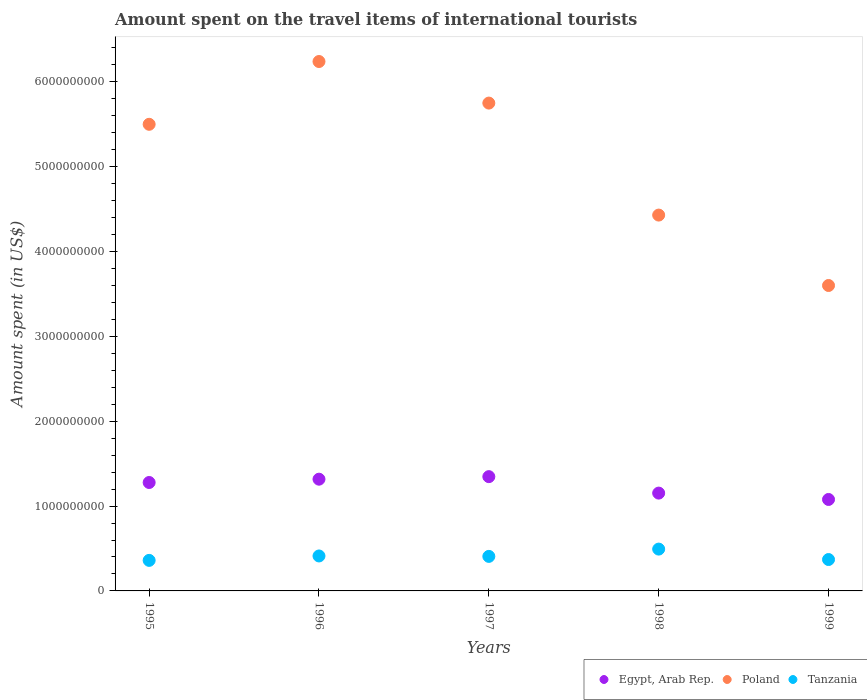How many different coloured dotlines are there?
Your response must be concise. 3. What is the amount spent on the travel items of international tourists in Poland in 1997?
Your response must be concise. 5.75e+09. Across all years, what is the maximum amount spent on the travel items of international tourists in Poland?
Offer a very short reply. 6.24e+09. Across all years, what is the minimum amount spent on the travel items of international tourists in Tanzania?
Your answer should be compact. 3.60e+08. In which year was the amount spent on the travel items of international tourists in Poland minimum?
Make the answer very short. 1999. What is the total amount spent on the travel items of international tourists in Tanzania in the graph?
Your answer should be compact. 2.04e+09. What is the difference between the amount spent on the travel items of international tourists in Egypt, Arab Rep. in 1998 and that in 1999?
Your answer should be very brief. 7.50e+07. What is the difference between the amount spent on the travel items of international tourists in Egypt, Arab Rep. in 1999 and the amount spent on the travel items of international tourists in Tanzania in 1996?
Your response must be concise. 6.66e+08. What is the average amount spent on the travel items of international tourists in Poland per year?
Provide a short and direct response. 5.10e+09. In the year 1996, what is the difference between the amount spent on the travel items of international tourists in Tanzania and amount spent on the travel items of international tourists in Egypt, Arab Rep.?
Make the answer very short. -9.05e+08. What is the ratio of the amount spent on the travel items of international tourists in Tanzania in 1997 to that in 1998?
Your answer should be compact. 0.83. What is the difference between the highest and the second highest amount spent on the travel items of international tourists in Poland?
Ensure brevity in your answer.  4.90e+08. What is the difference between the highest and the lowest amount spent on the travel items of international tourists in Poland?
Provide a succinct answer. 2.64e+09. Is it the case that in every year, the sum of the amount spent on the travel items of international tourists in Poland and amount spent on the travel items of international tourists in Tanzania  is greater than the amount spent on the travel items of international tourists in Egypt, Arab Rep.?
Ensure brevity in your answer.  Yes. Does the amount spent on the travel items of international tourists in Tanzania monotonically increase over the years?
Your answer should be very brief. No. How many dotlines are there?
Provide a succinct answer. 3. How many years are there in the graph?
Make the answer very short. 5. Where does the legend appear in the graph?
Provide a succinct answer. Bottom right. How many legend labels are there?
Provide a short and direct response. 3. What is the title of the graph?
Your response must be concise. Amount spent on the travel items of international tourists. What is the label or title of the Y-axis?
Give a very brief answer. Amount spent (in US$). What is the Amount spent (in US$) in Egypt, Arab Rep. in 1995?
Offer a very short reply. 1.28e+09. What is the Amount spent (in US$) of Poland in 1995?
Your response must be concise. 5.50e+09. What is the Amount spent (in US$) in Tanzania in 1995?
Make the answer very short. 3.60e+08. What is the Amount spent (in US$) in Egypt, Arab Rep. in 1996?
Give a very brief answer. 1.32e+09. What is the Amount spent (in US$) in Poland in 1996?
Ensure brevity in your answer.  6.24e+09. What is the Amount spent (in US$) in Tanzania in 1996?
Give a very brief answer. 4.12e+08. What is the Amount spent (in US$) in Egypt, Arab Rep. in 1997?
Offer a terse response. 1.35e+09. What is the Amount spent (in US$) in Poland in 1997?
Give a very brief answer. 5.75e+09. What is the Amount spent (in US$) in Tanzania in 1997?
Your answer should be compact. 4.07e+08. What is the Amount spent (in US$) of Egypt, Arab Rep. in 1998?
Provide a short and direct response. 1.15e+09. What is the Amount spent (in US$) of Poland in 1998?
Offer a terse response. 4.43e+09. What is the Amount spent (in US$) of Tanzania in 1998?
Your response must be concise. 4.93e+08. What is the Amount spent (in US$) of Egypt, Arab Rep. in 1999?
Your answer should be compact. 1.08e+09. What is the Amount spent (in US$) of Poland in 1999?
Keep it short and to the point. 3.60e+09. What is the Amount spent (in US$) in Tanzania in 1999?
Your response must be concise. 3.70e+08. Across all years, what is the maximum Amount spent (in US$) of Egypt, Arab Rep.?
Make the answer very short. 1.35e+09. Across all years, what is the maximum Amount spent (in US$) of Poland?
Provide a short and direct response. 6.24e+09. Across all years, what is the maximum Amount spent (in US$) of Tanzania?
Offer a terse response. 4.93e+08. Across all years, what is the minimum Amount spent (in US$) of Egypt, Arab Rep.?
Keep it short and to the point. 1.08e+09. Across all years, what is the minimum Amount spent (in US$) of Poland?
Offer a very short reply. 3.60e+09. Across all years, what is the minimum Amount spent (in US$) of Tanzania?
Make the answer very short. 3.60e+08. What is the total Amount spent (in US$) in Egypt, Arab Rep. in the graph?
Your answer should be compact. 6.17e+09. What is the total Amount spent (in US$) of Poland in the graph?
Offer a very short reply. 2.55e+1. What is the total Amount spent (in US$) in Tanzania in the graph?
Make the answer very short. 2.04e+09. What is the difference between the Amount spent (in US$) in Egypt, Arab Rep. in 1995 and that in 1996?
Your answer should be very brief. -3.90e+07. What is the difference between the Amount spent (in US$) in Poland in 1995 and that in 1996?
Your answer should be compact. -7.40e+08. What is the difference between the Amount spent (in US$) in Tanzania in 1995 and that in 1996?
Offer a terse response. -5.20e+07. What is the difference between the Amount spent (in US$) of Egypt, Arab Rep. in 1995 and that in 1997?
Your answer should be compact. -6.90e+07. What is the difference between the Amount spent (in US$) in Poland in 1995 and that in 1997?
Provide a short and direct response. -2.50e+08. What is the difference between the Amount spent (in US$) of Tanzania in 1995 and that in 1997?
Your answer should be very brief. -4.70e+07. What is the difference between the Amount spent (in US$) of Egypt, Arab Rep. in 1995 and that in 1998?
Your answer should be compact. 1.25e+08. What is the difference between the Amount spent (in US$) of Poland in 1995 and that in 1998?
Keep it short and to the point. 1.07e+09. What is the difference between the Amount spent (in US$) in Tanzania in 1995 and that in 1998?
Keep it short and to the point. -1.33e+08. What is the difference between the Amount spent (in US$) of Poland in 1995 and that in 1999?
Your response must be concise. 1.90e+09. What is the difference between the Amount spent (in US$) in Tanzania in 1995 and that in 1999?
Make the answer very short. -1.00e+07. What is the difference between the Amount spent (in US$) in Egypt, Arab Rep. in 1996 and that in 1997?
Offer a very short reply. -3.00e+07. What is the difference between the Amount spent (in US$) in Poland in 1996 and that in 1997?
Make the answer very short. 4.90e+08. What is the difference between the Amount spent (in US$) of Egypt, Arab Rep. in 1996 and that in 1998?
Give a very brief answer. 1.64e+08. What is the difference between the Amount spent (in US$) in Poland in 1996 and that in 1998?
Your answer should be compact. 1.81e+09. What is the difference between the Amount spent (in US$) in Tanzania in 1996 and that in 1998?
Keep it short and to the point. -8.10e+07. What is the difference between the Amount spent (in US$) in Egypt, Arab Rep. in 1996 and that in 1999?
Offer a terse response. 2.39e+08. What is the difference between the Amount spent (in US$) of Poland in 1996 and that in 1999?
Offer a terse response. 2.64e+09. What is the difference between the Amount spent (in US$) in Tanzania in 1996 and that in 1999?
Make the answer very short. 4.20e+07. What is the difference between the Amount spent (in US$) of Egypt, Arab Rep. in 1997 and that in 1998?
Your answer should be compact. 1.94e+08. What is the difference between the Amount spent (in US$) in Poland in 1997 and that in 1998?
Keep it short and to the point. 1.32e+09. What is the difference between the Amount spent (in US$) in Tanzania in 1997 and that in 1998?
Your answer should be compact. -8.60e+07. What is the difference between the Amount spent (in US$) in Egypt, Arab Rep. in 1997 and that in 1999?
Provide a short and direct response. 2.69e+08. What is the difference between the Amount spent (in US$) in Poland in 1997 and that in 1999?
Offer a terse response. 2.15e+09. What is the difference between the Amount spent (in US$) in Tanzania in 1997 and that in 1999?
Provide a succinct answer. 3.70e+07. What is the difference between the Amount spent (in US$) of Egypt, Arab Rep. in 1998 and that in 1999?
Give a very brief answer. 7.50e+07. What is the difference between the Amount spent (in US$) in Poland in 1998 and that in 1999?
Make the answer very short. 8.30e+08. What is the difference between the Amount spent (in US$) of Tanzania in 1998 and that in 1999?
Your response must be concise. 1.23e+08. What is the difference between the Amount spent (in US$) in Egypt, Arab Rep. in 1995 and the Amount spent (in US$) in Poland in 1996?
Provide a succinct answer. -4.96e+09. What is the difference between the Amount spent (in US$) in Egypt, Arab Rep. in 1995 and the Amount spent (in US$) in Tanzania in 1996?
Your answer should be compact. 8.66e+08. What is the difference between the Amount spent (in US$) of Poland in 1995 and the Amount spent (in US$) of Tanzania in 1996?
Offer a very short reply. 5.09e+09. What is the difference between the Amount spent (in US$) in Egypt, Arab Rep. in 1995 and the Amount spent (in US$) in Poland in 1997?
Keep it short and to the point. -4.47e+09. What is the difference between the Amount spent (in US$) of Egypt, Arab Rep. in 1995 and the Amount spent (in US$) of Tanzania in 1997?
Offer a very short reply. 8.71e+08. What is the difference between the Amount spent (in US$) of Poland in 1995 and the Amount spent (in US$) of Tanzania in 1997?
Make the answer very short. 5.09e+09. What is the difference between the Amount spent (in US$) of Egypt, Arab Rep. in 1995 and the Amount spent (in US$) of Poland in 1998?
Provide a succinct answer. -3.15e+09. What is the difference between the Amount spent (in US$) of Egypt, Arab Rep. in 1995 and the Amount spent (in US$) of Tanzania in 1998?
Offer a terse response. 7.85e+08. What is the difference between the Amount spent (in US$) of Poland in 1995 and the Amount spent (in US$) of Tanzania in 1998?
Offer a terse response. 5.01e+09. What is the difference between the Amount spent (in US$) in Egypt, Arab Rep. in 1995 and the Amount spent (in US$) in Poland in 1999?
Your answer should be compact. -2.32e+09. What is the difference between the Amount spent (in US$) of Egypt, Arab Rep. in 1995 and the Amount spent (in US$) of Tanzania in 1999?
Your answer should be compact. 9.08e+08. What is the difference between the Amount spent (in US$) of Poland in 1995 and the Amount spent (in US$) of Tanzania in 1999?
Your response must be concise. 5.13e+09. What is the difference between the Amount spent (in US$) of Egypt, Arab Rep. in 1996 and the Amount spent (in US$) of Poland in 1997?
Offer a very short reply. -4.43e+09. What is the difference between the Amount spent (in US$) in Egypt, Arab Rep. in 1996 and the Amount spent (in US$) in Tanzania in 1997?
Ensure brevity in your answer.  9.10e+08. What is the difference between the Amount spent (in US$) of Poland in 1996 and the Amount spent (in US$) of Tanzania in 1997?
Give a very brief answer. 5.83e+09. What is the difference between the Amount spent (in US$) in Egypt, Arab Rep. in 1996 and the Amount spent (in US$) in Poland in 1998?
Your answer should be very brief. -3.11e+09. What is the difference between the Amount spent (in US$) in Egypt, Arab Rep. in 1996 and the Amount spent (in US$) in Tanzania in 1998?
Your answer should be very brief. 8.24e+08. What is the difference between the Amount spent (in US$) in Poland in 1996 and the Amount spent (in US$) in Tanzania in 1998?
Keep it short and to the point. 5.75e+09. What is the difference between the Amount spent (in US$) in Egypt, Arab Rep. in 1996 and the Amount spent (in US$) in Poland in 1999?
Your answer should be compact. -2.28e+09. What is the difference between the Amount spent (in US$) of Egypt, Arab Rep. in 1996 and the Amount spent (in US$) of Tanzania in 1999?
Offer a terse response. 9.47e+08. What is the difference between the Amount spent (in US$) of Poland in 1996 and the Amount spent (in US$) of Tanzania in 1999?
Keep it short and to the point. 5.87e+09. What is the difference between the Amount spent (in US$) of Egypt, Arab Rep. in 1997 and the Amount spent (in US$) of Poland in 1998?
Give a very brief answer. -3.08e+09. What is the difference between the Amount spent (in US$) of Egypt, Arab Rep. in 1997 and the Amount spent (in US$) of Tanzania in 1998?
Provide a succinct answer. 8.54e+08. What is the difference between the Amount spent (in US$) of Poland in 1997 and the Amount spent (in US$) of Tanzania in 1998?
Give a very brief answer. 5.26e+09. What is the difference between the Amount spent (in US$) of Egypt, Arab Rep. in 1997 and the Amount spent (in US$) of Poland in 1999?
Provide a short and direct response. -2.25e+09. What is the difference between the Amount spent (in US$) in Egypt, Arab Rep. in 1997 and the Amount spent (in US$) in Tanzania in 1999?
Your answer should be very brief. 9.77e+08. What is the difference between the Amount spent (in US$) in Poland in 1997 and the Amount spent (in US$) in Tanzania in 1999?
Make the answer very short. 5.38e+09. What is the difference between the Amount spent (in US$) in Egypt, Arab Rep. in 1998 and the Amount spent (in US$) in Poland in 1999?
Give a very brief answer. -2.45e+09. What is the difference between the Amount spent (in US$) in Egypt, Arab Rep. in 1998 and the Amount spent (in US$) in Tanzania in 1999?
Your answer should be very brief. 7.83e+08. What is the difference between the Amount spent (in US$) in Poland in 1998 and the Amount spent (in US$) in Tanzania in 1999?
Provide a succinct answer. 4.06e+09. What is the average Amount spent (in US$) in Egypt, Arab Rep. per year?
Give a very brief answer. 1.23e+09. What is the average Amount spent (in US$) of Poland per year?
Provide a succinct answer. 5.10e+09. What is the average Amount spent (in US$) of Tanzania per year?
Keep it short and to the point. 4.08e+08. In the year 1995, what is the difference between the Amount spent (in US$) in Egypt, Arab Rep. and Amount spent (in US$) in Poland?
Provide a succinct answer. -4.22e+09. In the year 1995, what is the difference between the Amount spent (in US$) of Egypt, Arab Rep. and Amount spent (in US$) of Tanzania?
Keep it short and to the point. 9.18e+08. In the year 1995, what is the difference between the Amount spent (in US$) in Poland and Amount spent (in US$) in Tanzania?
Provide a short and direct response. 5.14e+09. In the year 1996, what is the difference between the Amount spent (in US$) of Egypt, Arab Rep. and Amount spent (in US$) of Poland?
Provide a succinct answer. -4.92e+09. In the year 1996, what is the difference between the Amount spent (in US$) in Egypt, Arab Rep. and Amount spent (in US$) in Tanzania?
Your response must be concise. 9.05e+08. In the year 1996, what is the difference between the Amount spent (in US$) in Poland and Amount spent (in US$) in Tanzania?
Give a very brief answer. 5.83e+09. In the year 1997, what is the difference between the Amount spent (in US$) of Egypt, Arab Rep. and Amount spent (in US$) of Poland?
Ensure brevity in your answer.  -4.40e+09. In the year 1997, what is the difference between the Amount spent (in US$) of Egypt, Arab Rep. and Amount spent (in US$) of Tanzania?
Ensure brevity in your answer.  9.40e+08. In the year 1997, what is the difference between the Amount spent (in US$) of Poland and Amount spent (in US$) of Tanzania?
Offer a very short reply. 5.34e+09. In the year 1998, what is the difference between the Amount spent (in US$) of Egypt, Arab Rep. and Amount spent (in US$) of Poland?
Provide a short and direct response. -3.28e+09. In the year 1998, what is the difference between the Amount spent (in US$) of Egypt, Arab Rep. and Amount spent (in US$) of Tanzania?
Keep it short and to the point. 6.60e+08. In the year 1998, what is the difference between the Amount spent (in US$) of Poland and Amount spent (in US$) of Tanzania?
Provide a succinct answer. 3.94e+09. In the year 1999, what is the difference between the Amount spent (in US$) in Egypt, Arab Rep. and Amount spent (in US$) in Poland?
Provide a short and direct response. -2.52e+09. In the year 1999, what is the difference between the Amount spent (in US$) in Egypt, Arab Rep. and Amount spent (in US$) in Tanzania?
Provide a short and direct response. 7.08e+08. In the year 1999, what is the difference between the Amount spent (in US$) in Poland and Amount spent (in US$) in Tanzania?
Ensure brevity in your answer.  3.23e+09. What is the ratio of the Amount spent (in US$) in Egypt, Arab Rep. in 1995 to that in 1996?
Provide a succinct answer. 0.97. What is the ratio of the Amount spent (in US$) of Poland in 1995 to that in 1996?
Make the answer very short. 0.88. What is the ratio of the Amount spent (in US$) of Tanzania in 1995 to that in 1996?
Provide a short and direct response. 0.87. What is the ratio of the Amount spent (in US$) in Egypt, Arab Rep. in 1995 to that in 1997?
Provide a succinct answer. 0.95. What is the ratio of the Amount spent (in US$) in Poland in 1995 to that in 1997?
Provide a succinct answer. 0.96. What is the ratio of the Amount spent (in US$) of Tanzania in 1995 to that in 1997?
Give a very brief answer. 0.88. What is the ratio of the Amount spent (in US$) of Egypt, Arab Rep. in 1995 to that in 1998?
Your answer should be very brief. 1.11. What is the ratio of the Amount spent (in US$) of Poland in 1995 to that in 1998?
Ensure brevity in your answer.  1.24. What is the ratio of the Amount spent (in US$) of Tanzania in 1995 to that in 1998?
Provide a short and direct response. 0.73. What is the ratio of the Amount spent (in US$) in Egypt, Arab Rep. in 1995 to that in 1999?
Offer a very short reply. 1.19. What is the ratio of the Amount spent (in US$) of Poland in 1995 to that in 1999?
Make the answer very short. 1.53. What is the ratio of the Amount spent (in US$) of Egypt, Arab Rep. in 1996 to that in 1997?
Ensure brevity in your answer.  0.98. What is the ratio of the Amount spent (in US$) in Poland in 1996 to that in 1997?
Your answer should be compact. 1.09. What is the ratio of the Amount spent (in US$) in Tanzania in 1996 to that in 1997?
Provide a short and direct response. 1.01. What is the ratio of the Amount spent (in US$) of Egypt, Arab Rep. in 1996 to that in 1998?
Ensure brevity in your answer.  1.14. What is the ratio of the Amount spent (in US$) in Poland in 1996 to that in 1998?
Your response must be concise. 1.41. What is the ratio of the Amount spent (in US$) in Tanzania in 1996 to that in 1998?
Your answer should be compact. 0.84. What is the ratio of the Amount spent (in US$) of Egypt, Arab Rep. in 1996 to that in 1999?
Ensure brevity in your answer.  1.22. What is the ratio of the Amount spent (in US$) in Poland in 1996 to that in 1999?
Keep it short and to the point. 1.73. What is the ratio of the Amount spent (in US$) of Tanzania in 1996 to that in 1999?
Give a very brief answer. 1.11. What is the ratio of the Amount spent (in US$) of Egypt, Arab Rep. in 1997 to that in 1998?
Ensure brevity in your answer.  1.17. What is the ratio of the Amount spent (in US$) in Poland in 1997 to that in 1998?
Your answer should be compact. 1.3. What is the ratio of the Amount spent (in US$) of Tanzania in 1997 to that in 1998?
Give a very brief answer. 0.83. What is the ratio of the Amount spent (in US$) of Egypt, Arab Rep. in 1997 to that in 1999?
Provide a succinct answer. 1.25. What is the ratio of the Amount spent (in US$) in Poland in 1997 to that in 1999?
Offer a terse response. 1.6. What is the ratio of the Amount spent (in US$) of Tanzania in 1997 to that in 1999?
Give a very brief answer. 1.1. What is the ratio of the Amount spent (in US$) of Egypt, Arab Rep. in 1998 to that in 1999?
Your response must be concise. 1.07. What is the ratio of the Amount spent (in US$) of Poland in 1998 to that in 1999?
Give a very brief answer. 1.23. What is the ratio of the Amount spent (in US$) in Tanzania in 1998 to that in 1999?
Make the answer very short. 1.33. What is the difference between the highest and the second highest Amount spent (in US$) in Egypt, Arab Rep.?
Offer a terse response. 3.00e+07. What is the difference between the highest and the second highest Amount spent (in US$) of Poland?
Ensure brevity in your answer.  4.90e+08. What is the difference between the highest and the second highest Amount spent (in US$) in Tanzania?
Give a very brief answer. 8.10e+07. What is the difference between the highest and the lowest Amount spent (in US$) in Egypt, Arab Rep.?
Your answer should be very brief. 2.69e+08. What is the difference between the highest and the lowest Amount spent (in US$) in Poland?
Keep it short and to the point. 2.64e+09. What is the difference between the highest and the lowest Amount spent (in US$) in Tanzania?
Offer a terse response. 1.33e+08. 